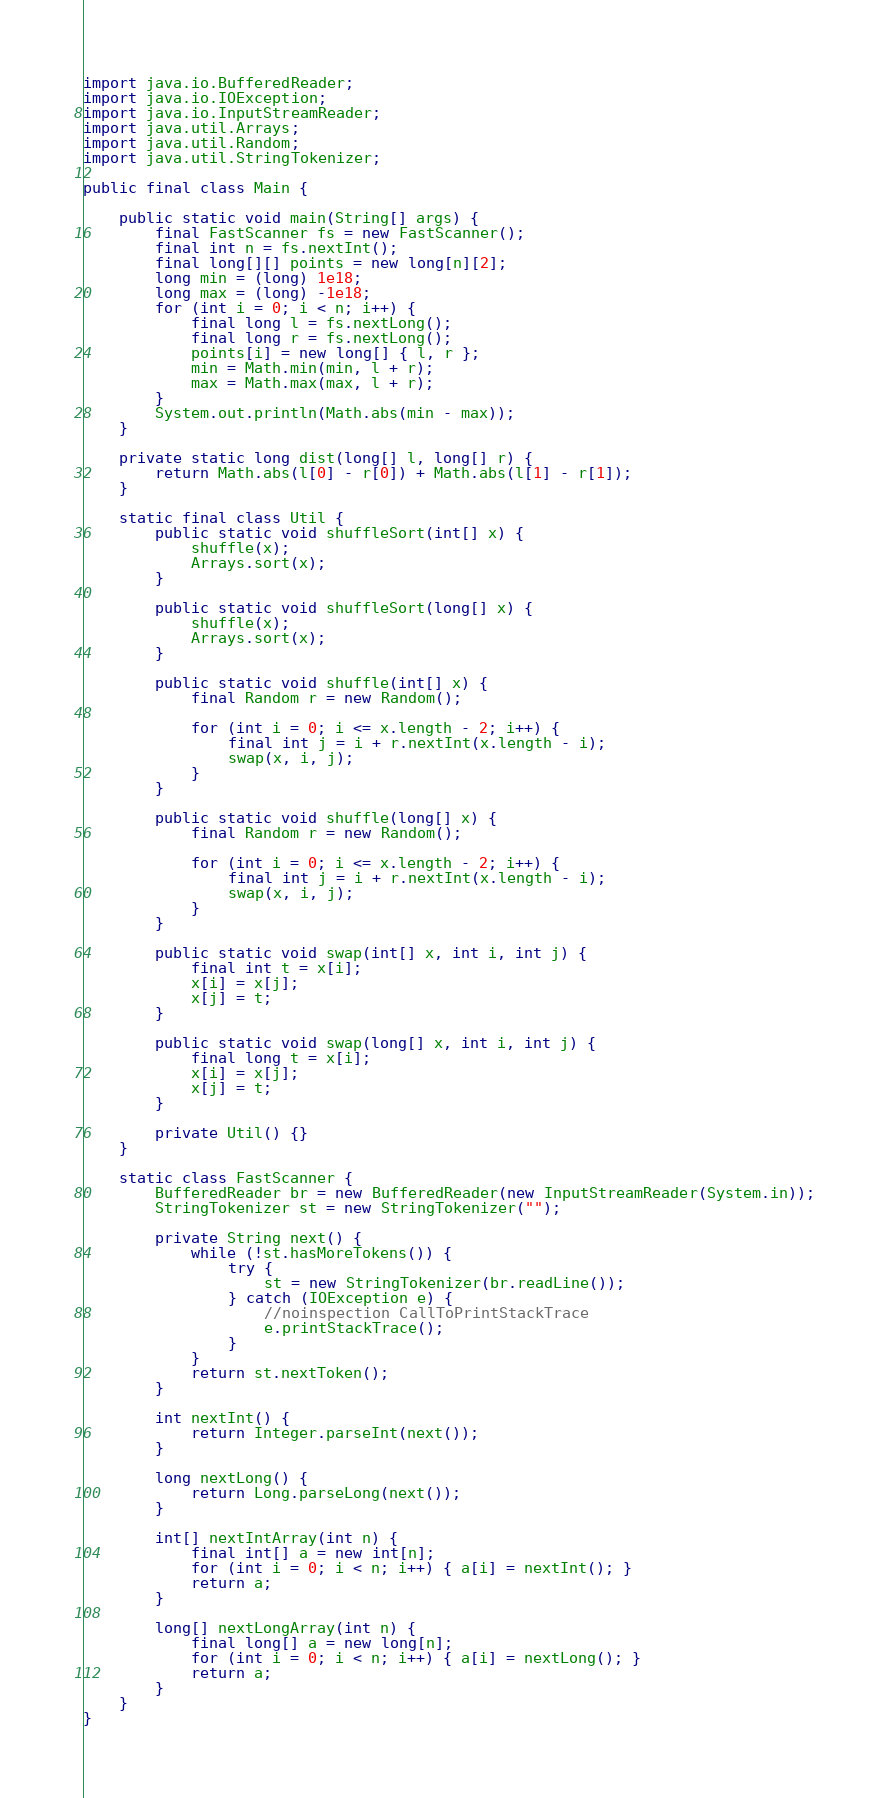<code> <loc_0><loc_0><loc_500><loc_500><_Java_>
import java.io.BufferedReader;
import java.io.IOException;
import java.io.InputStreamReader;
import java.util.Arrays;
import java.util.Random;
import java.util.StringTokenizer;

public final class Main {

    public static void main(String[] args) {
        final FastScanner fs = new FastScanner();
        final int n = fs.nextInt();
        final long[][] points = new long[n][2];
        long min = (long) 1e18;
        long max = (long) -1e18;
        for (int i = 0; i < n; i++) {
            final long l = fs.nextLong();
            final long r = fs.nextLong();
            points[i] = new long[] { l, r };
            min = Math.min(min, l + r);
            max = Math.max(max, l + r);
        }
        System.out.println(Math.abs(min - max));
    }

    private static long dist(long[] l, long[] r) {
        return Math.abs(l[0] - r[0]) + Math.abs(l[1] - r[1]);
    }

    static final class Util {
        public static void shuffleSort(int[] x) {
            shuffle(x);
            Arrays.sort(x);
        }

        public static void shuffleSort(long[] x) {
            shuffle(x);
            Arrays.sort(x);
        }

        public static void shuffle(int[] x) {
            final Random r = new Random();

            for (int i = 0; i <= x.length - 2; i++) {
                final int j = i + r.nextInt(x.length - i);
                swap(x, i, j);
            }
        }

        public static void shuffle(long[] x) {
            final Random r = new Random();

            for (int i = 0; i <= x.length - 2; i++) {
                final int j = i + r.nextInt(x.length - i);
                swap(x, i, j);
            }
        }

        public static void swap(int[] x, int i, int j) {
            final int t = x[i];
            x[i] = x[j];
            x[j] = t;
        }

        public static void swap(long[] x, int i, int j) {
            final long t = x[i];
            x[i] = x[j];
            x[j] = t;
        }

        private Util() {}
    }

    static class FastScanner {
        BufferedReader br = new BufferedReader(new InputStreamReader(System.in));
        StringTokenizer st = new StringTokenizer("");

        private String next() {
            while (!st.hasMoreTokens()) {
                try {
                    st = new StringTokenizer(br.readLine());
                } catch (IOException e) {
                    //noinspection CallToPrintStackTrace
                    e.printStackTrace();
                }
            }
            return st.nextToken();
        }

        int nextInt() {
            return Integer.parseInt(next());
        }

        long nextLong() {
            return Long.parseLong(next());
        }

        int[] nextIntArray(int n) {
            final int[] a = new int[n];
            for (int i = 0; i < n; i++) { a[i] = nextInt(); }
            return a;
        }

        long[] nextLongArray(int n) {
            final long[] a = new long[n];
            for (int i = 0; i < n; i++) { a[i] = nextLong(); }
            return a;
        }
    }
}
</code> 